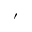Convert formula to latex. <formula><loc_0><loc_0><loc_500><loc_500>^ { \prime }</formula> 